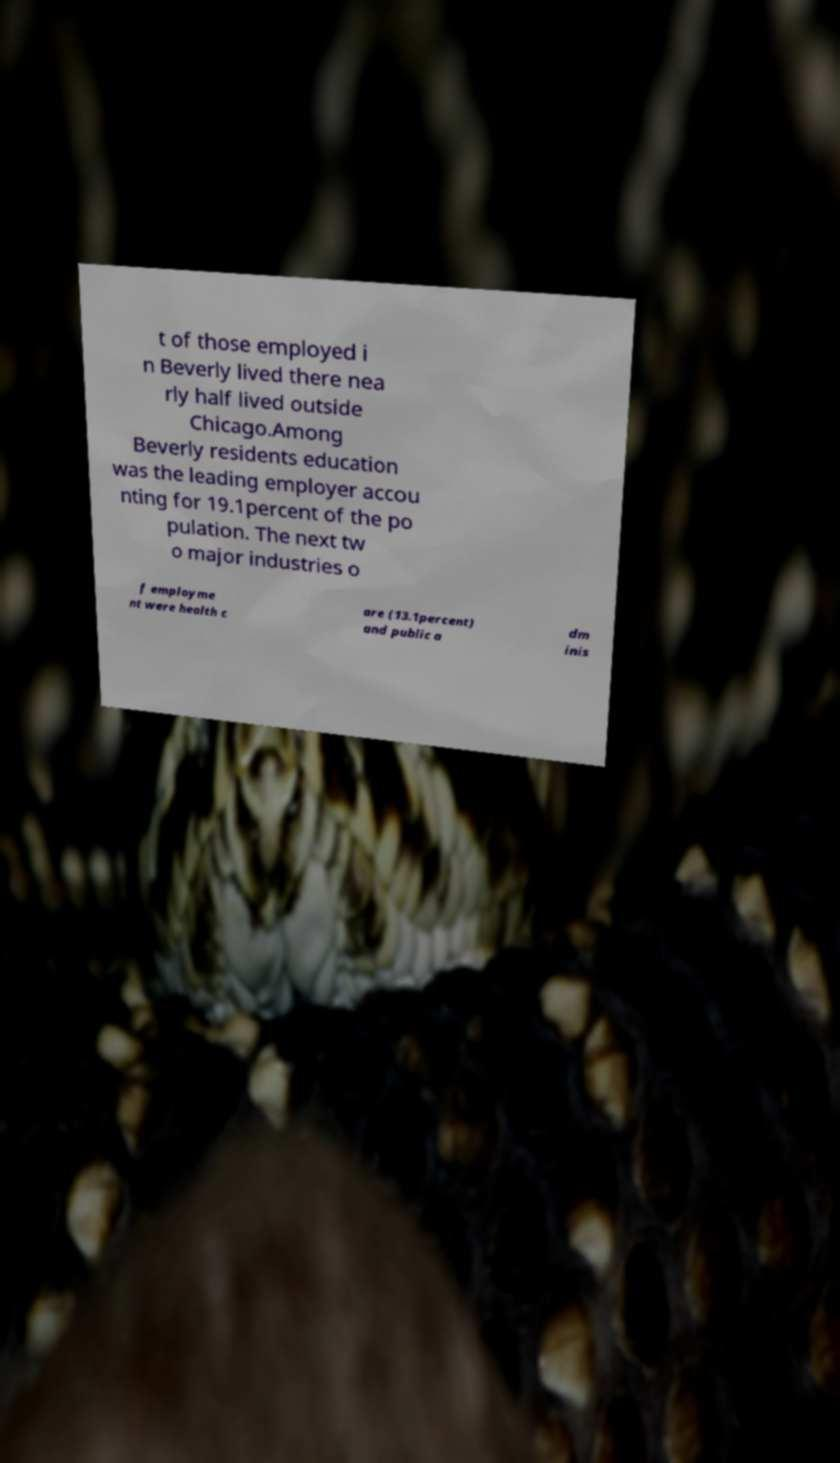Can you accurately transcribe the text from the provided image for me? t of those employed i n Beverly lived there nea rly half lived outside Chicago.Among Beverly residents education was the leading employer accou nting for 19.1percent of the po pulation. The next tw o major industries o f employme nt were health c are (13.1percent) and public a dm inis 